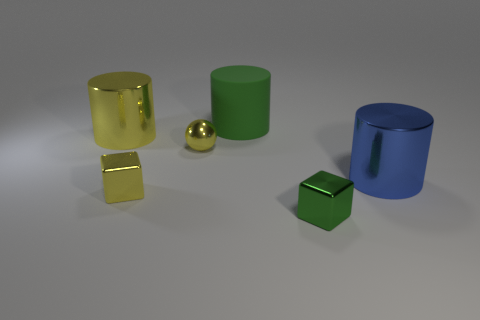Subtract all shiny cylinders. How many cylinders are left? 1 Add 2 large rubber cylinders. How many objects exist? 8 Subtract all spheres. How many objects are left? 5 Subtract all cyan cylinders. Subtract all cyan blocks. How many cylinders are left? 3 Add 2 big shiny things. How many big shiny things exist? 4 Subtract 0 purple spheres. How many objects are left? 6 Subtract all blue things. Subtract all green matte cylinders. How many objects are left? 4 Add 3 tiny yellow metal spheres. How many tiny yellow metal spheres are left? 4 